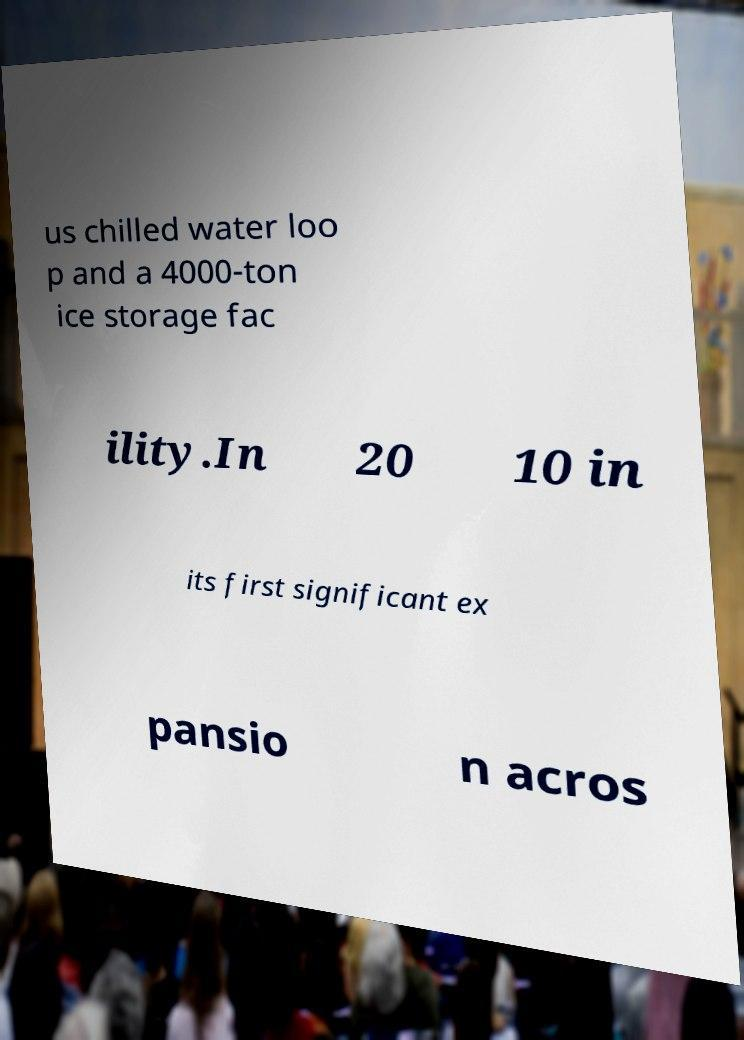Could you extract and type out the text from this image? us chilled water loo p and a 4000-ton ice storage fac ility.In 20 10 in its first significant ex pansio n acros 